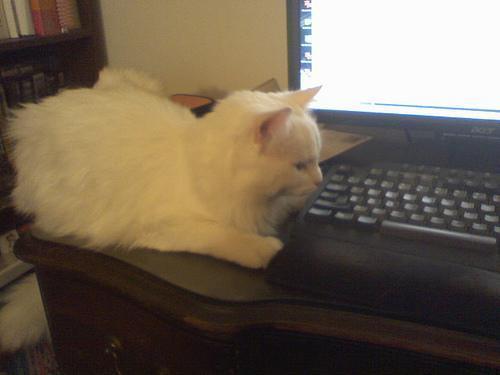How many trains are on the tracks?
Give a very brief answer. 0. 